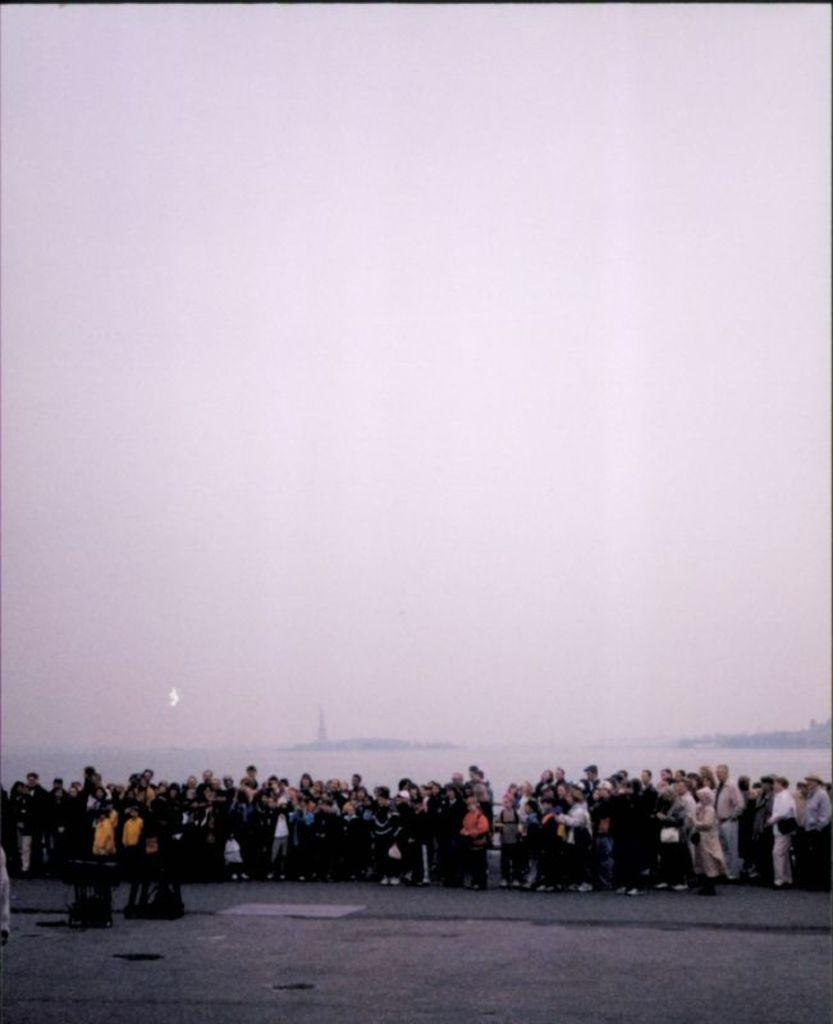What is the main subject of the image? The main subject of the image is a group of people standing. What can be seen in the background of the image? There is a road and a lake visible in the image. What is visible at the top of the image? The sky is visible at the top of the image. What type of station is located near the lake in the image? There is no station present in the image; it only features a group of people standing, a road, a lake, and the sky. Can you describe the facial expressions of the people in the image? The provided facts do not mention any facial expressions of the people in the image, so we cannot describe them. 